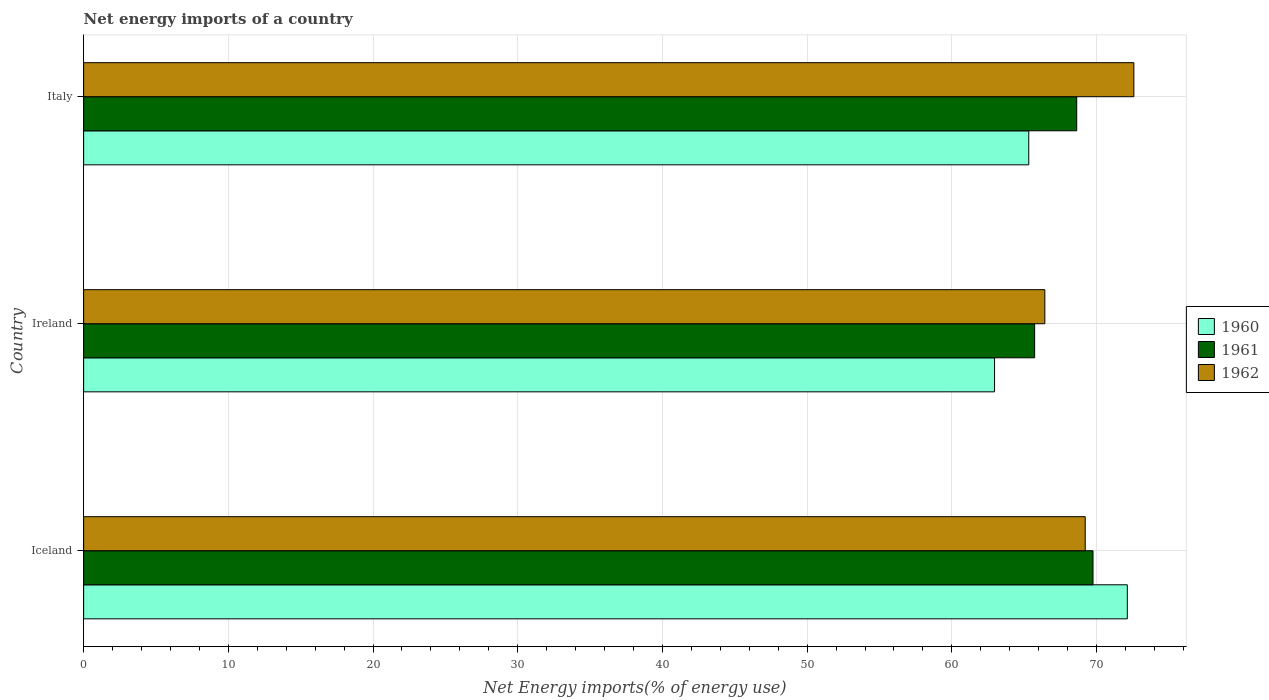How many groups of bars are there?
Offer a very short reply. 3. Are the number of bars per tick equal to the number of legend labels?
Offer a terse response. Yes. Are the number of bars on each tick of the Y-axis equal?
Your answer should be very brief. Yes. How many bars are there on the 3rd tick from the bottom?
Provide a short and direct response. 3. What is the net energy imports in 1961 in Iceland?
Offer a terse response. 69.76. Across all countries, what is the maximum net energy imports in 1961?
Your answer should be compact. 69.76. Across all countries, what is the minimum net energy imports in 1962?
Provide a short and direct response. 66.43. In which country was the net energy imports in 1961 minimum?
Provide a short and direct response. Ireland. What is the total net energy imports in 1961 in the graph?
Offer a very short reply. 204.11. What is the difference between the net energy imports in 1960 in Iceland and that in Italy?
Offer a very short reply. 6.81. What is the difference between the net energy imports in 1960 in Ireland and the net energy imports in 1962 in Iceland?
Provide a short and direct response. -6.27. What is the average net energy imports in 1960 per country?
Your answer should be compact. 66.8. What is the difference between the net energy imports in 1962 and net energy imports in 1960 in Ireland?
Offer a very short reply. 3.47. What is the ratio of the net energy imports in 1960 in Iceland to that in Ireland?
Provide a short and direct response. 1.15. Is the net energy imports in 1960 in Iceland less than that in Ireland?
Make the answer very short. No. Is the difference between the net energy imports in 1962 in Iceland and Italy greater than the difference between the net energy imports in 1960 in Iceland and Italy?
Your answer should be compact. No. What is the difference between the highest and the second highest net energy imports in 1960?
Provide a succinct answer. 6.81. What is the difference between the highest and the lowest net energy imports in 1961?
Provide a succinct answer. 4.03. In how many countries, is the net energy imports in 1962 greater than the average net energy imports in 1962 taken over all countries?
Your answer should be very brief. 1. What does the 3rd bar from the top in Ireland represents?
Give a very brief answer. 1960. Is it the case that in every country, the sum of the net energy imports in 1960 and net energy imports in 1961 is greater than the net energy imports in 1962?
Ensure brevity in your answer.  Yes. Are all the bars in the graph horizontal?
Ensure brevity in your answer.  Yes. Does the graph contain any zero values?
Offer a terse response. No. Does the graph contain grids?
Provide a short and direct response. Yes. Where does the legend appear in the graph?
Ensure brevity in your answer.  Center right. How many legend labels are there?
Provide a short and direct response. 3. How are the legend labels stacked?
Provide a short and direct response. Vertical. What is the title of the graph?
Make the answer very short. Net energy imports of a country. What is the label or title of the X-axis?
Your answer should be very brief. Net Energy imports(% of energy use). What is the label or title of the Y-axis?
Make the answer very short. Country. What is the Net Energy imports(% of energy use) in 1960 in Iceland?
Provide a succinct answer. 72.13. What is the Net Energy imports(% of energy use) in 1961 in Iceland?
Make the answer very short. 69.76. What is the Net Energy imports(% of energy use) in 1962 in Iceland?
Make the answer very short. 69.22. What is the Net Energy imports(% of energy use) of 1960 in Ireland?
Make the answer very short. 62.95. What is the Net Energy imports(% of energy use) in 1961 in Ireland?
Ensure brevity in your answer.  65.72. What is the Net Energy imports(% of energy use) of 1962 in Ireland?
Make the answer very short. 66.43. What is the Net Energy imports(% of energy use) of 1960 in Italy?
Your answer should be very brief. 65.32. What is the Net Energy imports(% of energy use) in 1961 in Italy?
Your answer should be very brief. 68.63. What is the Net Energy imports(% of energy use) in 1962 in Italy?
Give a very brief answer. 72.58. Across all countries, what is the maximum Net Energy imports(% of energy use) of 1960?
Your response must be concise. 72.13. Across all countries, what is the maximum Net Energy imports(% of energy use) of 1961?
Give a very brief answer. 69.76. Across all countries, what is the maximum Net Energy imports(% of energy use) in 1962?
Offer a very short reply. 72.58. Across all countries, what is the minimum Net Energy imports(% of energy use) of 1960?
Provide a short and direct response. 62.95. Across all countries, what is the minimum Net Energy imports(% of energy use) in 1961?
Offer a terse response. 65.72. Across all countries, what is the minimum Net Energy imports(% of energy use) of 1962?
Your answer should be very brief. 66.43. What is the total Net Energy imports(% of energy use) in 1960 in the graph?
Your answer should be compact. 200.4. What is the total Net Energy imports(% of energy use) of 1961 in the graph?
Make the answer very short. 204.11. What is the total Net Energy imports(% of energy use) in 1962 in the graph?
Your answer should be very brief. 208.22. What is the difference between the Net Energy imports(% of energy use) of 1960 in Iceland and that in Ireland?
Make the answer very short. 9.18. What is the difference between the Net Energy imports(% of energy use) in 1961 in Iceland and that in Ireland?
Your response must be concise. 4.03. What is the difference between the Net Energy imports(% of energy use) in 1962 in Iceland and that in Ireland?
Your answer should be compact. 2.79. What is the difference between the Net Energy imports(% of energy use) in 1960 in Iceland and that in Italy?
Your answer should be very brief. 6.81. What is the difference between the Net Energy imports(% of energy use) of 1961 in Iceland and that in Italy?
Your answer should be compact. 1.13. What is the difference between the Net Energy imports(% of energy use) in 1962 in Iceland and that in Italy?
Your answer should be compact. -3.36. What is the difference between the Net Energy imports(% of energy use) in 1960 in Ireland and that in Italy?
Your answer should be compact. -2.36. What is the difference between the Net Energy imports(% of energy use) of 1961 in Ireland and that in Italy?
Offer a very short reply. -2.91. What is the difference between the Net Energy imports(% of energy use) of 1962 in Ireland and that in Italy?
Keep it short and to the point. -6.15. What is the difference between the Net Energy imports(% of energy use) in 1960 in Iceland and the Net Energy imports(% of energy use) in 1961 in Ireland?
Offer a very short reply. 6.41. What is the difference between the Net Energy imports(% of energy use) of 1960 in Iceland and the Net Energy imports(% of energy use) of 1962 in Ireland?
Your answer should be very brief. 5.7. What is the difference between the Net Energy imports(% of energy use) in 1961 in Iceland and the Net Energy imports(% of energy use) in 1962 in Ireland?
Make the answer very short. 3.33. What is the difference between the Net Energy imports(% of energy use) in 1960 in Iceland and the Net Energy imports(% of energy use) in 1961 in Italy?
Provide a succinct answer. 3.5. What is the difference between the Net Energy imports(% of energy use) of 1960 in Iceland and the Net Energy imports(% of energy use) of 1962 in Italy?
Your response must be concise. -0.45. What is the difference between the Net Energy imports(% of energy use) of 1961 in Iceland and the Net Energy imports(% of energy use) of 1962 in Italy?
Keep it short and to the point. -2.82. What is the difference between the Net Energy imports(% of energy use) of 1960 in Ireland and the Net Energy imports(% of energy use) of 1961 in Italy?
Provide a succinct answer. -5.68. What is the difference between the Net Energy imports(% of energy use) of 1960 in Ireland and the Net Energy imports(% of energy use) of 1962 in Italy?
Your response must be concise. -9.63. What is the difference between the Net Energy imports(% of energy use) in 1961 in Ireland and the Net Energy imports(% of energy use) in 1962 in Italy?
Ensure brevity in your answer.  -6.86. What is the average Net Energy imports(% of energy use) of 1960 per country?
Your answer should be compact. 66.8. What is the average Net Energy imports(% of energy use) of 1961 per country?
Provide a succinct answer. 68.04. What is the average Net Energy imports(% of energy use) of 1962 per country?
Your answer should be compact. 69.41. What is the difference between the Net Energy imports(% of energy use) of 1960 and Net Energy imports(% of energy use) of 1961 in Iceland?
Your response must be concise. 2.37. What is the difference between the Net Energy imports(% of energy use) of 1960 and Net Energy imports(% of energy use) of 1962 in Iceland?
Offer a terse response. 2.91. What is the difference between the Net Energy imports(% of energy use) of 1961 and Net Energy imports(% of energy use) of 1962 in Iceland?
Give a very brief answer. 0.54. What is the difference between the Net Energy imports(% of energy use) in 1960 and Net Energy imports(% of energy use) in 1961 in Ireland?
Offer a very short reply. -2.77. What is the difference between the Net Energy imports(% of energy use) in 1960 and Net Energy imports(% of energy use) in 1962 in Ireland?
Your answer should be compact. -3.47. What is the difference between the Net Energy imports(% of energy use) of 1961 and Net Energy imports(% of energy use) of 1962 in Ireland?
Give a very brief answer. -0.7. What is the difference between the Net Energy imports(% of energy use) in 1960 and Net Energy imports(% of energy use) in 1961 in Italy?
Provide a succinct answer. -3.31. What is the difference between the Net Energy imports(% of energy use) in 1960 and Net Energy imports(% of energy use) in 1962 in Italy?
Your answer should be compact. -7.26. What is the difference between the Net Energy imports(% of energy use) of 1961 and Net Energy imports(% of energy use) of 1962 in Italy?
Give a very brief answer. -3.95. What is the ratio of the Net Energy imports(% of energy use) of 1960 in Iceland to that in Ireland?
Provide a succinct answer. 1.15. What is the ratio of the Net Energy imports(% of energy use) of 1961 in Iceland to that in Ireland?
Ensure brevity in your answer.  1.06. What is the ratio of the Net Energy imports(% of energy use) in 1962 in Iceland to that in Ireland?
Your response must be concise. 1.04. What is the ratio of the Net Energy imports(% of energy use) in 1960 in Iceland to that in Italy?
Your answer should be compact. 1.1. What is the ratio of the Net Energy imports(% of energy use) in 1961 in Iceland to that in Italy?
Give a very brief answer. 1.02. What is the ratio of the Net Energy imports(% of energy use) in 1962 in Iceland to that in Italy?
Offer a very short reply. 0.95. What is the ratio of the Net Energy imports(% of energy use) of 1960 in Ireland to that in Italy?
Keep it short and to the point. 0.96. What is the ratio of the Net Energy imports(% of energy use) in 1961 in Ireland to that in Italy?
Your response must be concise. 0.96. What is the ratio of the Net Energy imports(% of energy use) in 1962 in Ireland to that in Italy?
Ensure brevity in your answer.  0.92. What is the difference between the highest and the second highest Net Energy imports(% of energy use) of 1960?
Make the answer very short. 6.81. What is the difference between the highest and the second highest Net Energy imports(% of energy use) of 1961?
Ensure brevity in your answer.  1.13. What is the difference between the highest and the second highest Net Energy imports(% of energy use) of 1962?
Ensure brevity in your answer.  3.36. What is the difference between the highest and the lowest Net Energy imports(% of energy use) in 1960?
Make the answer very short. 9.18. What is the difference between the highest and the lowest Net Energy imports(% of energy use) of 1961?
Provide a short and direct response. 4.03. What is the difference between the highest and the lowest Net Energy imports(% of energy use) in 1962?
Offer a terse response. 6.15. 